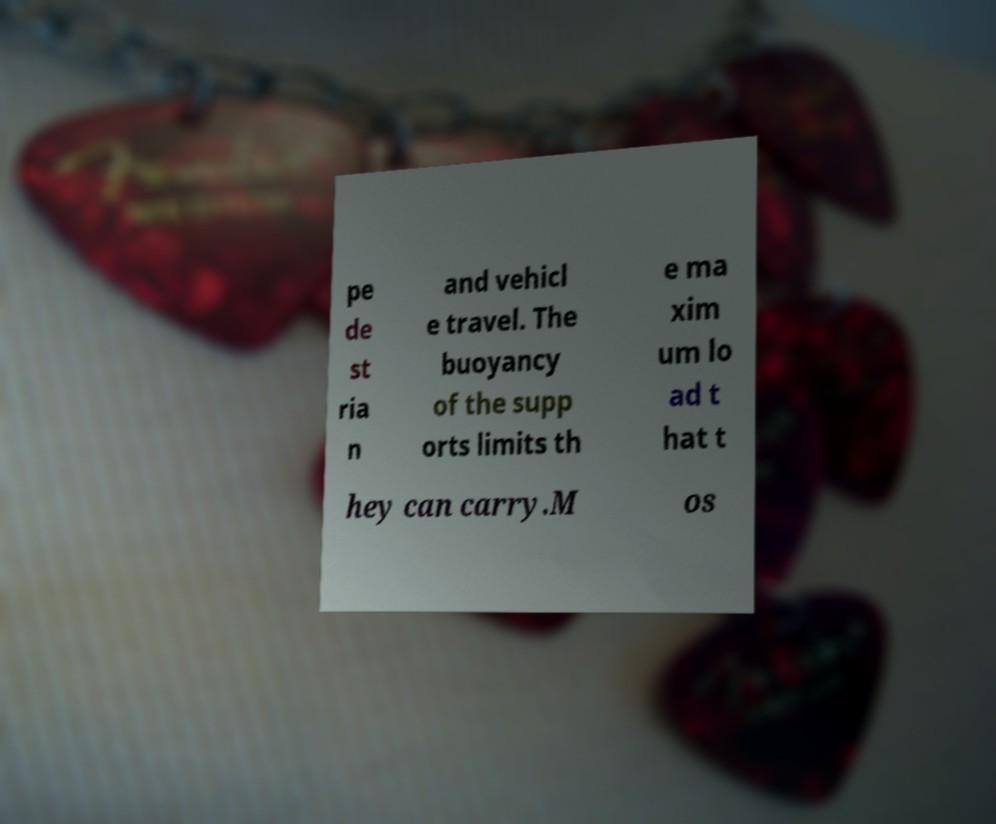I need the written content from this picture converted into text. Can you do that? pe de st ria n and vehicl e travel. The buoyancy of the supp orts limits th e ma xim um lo ad t hat t hey can carry.M os 